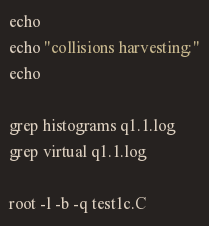<code> <loc_0><loc_0><loc_500><loc_500><_Bash_>
echo
echo "collisions harvesting:"
echo

grep histograms q1.1.log
grep virtual q1.1.log

root -l -b -q test1c.C

</code> 